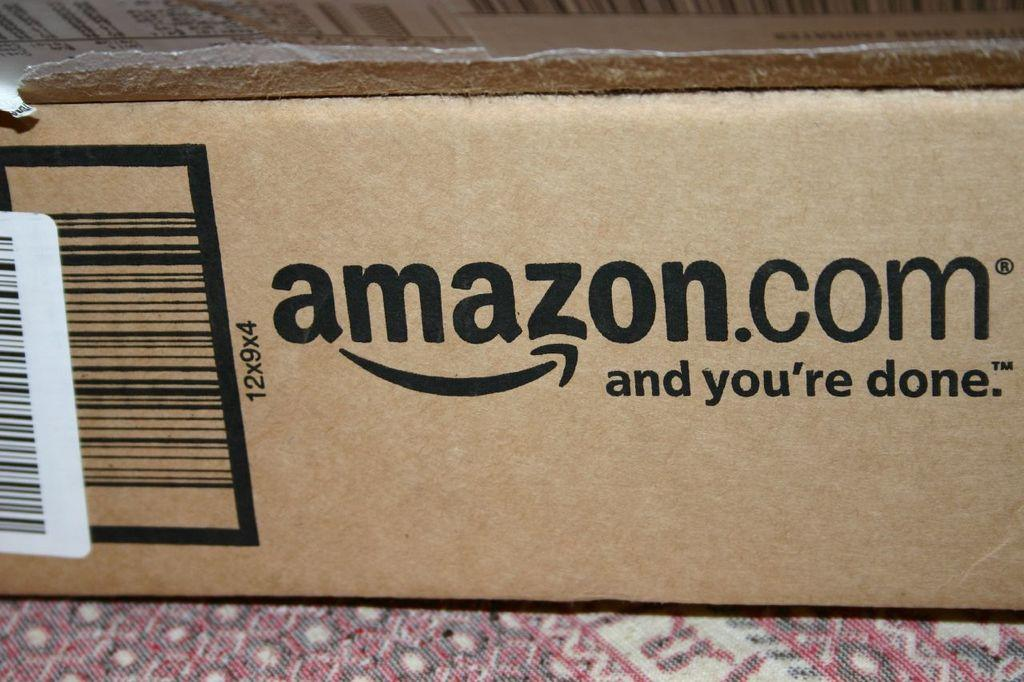<image>
Provide a brief description of the given image. The cardboard box advertises the amazon.com website along the side. 